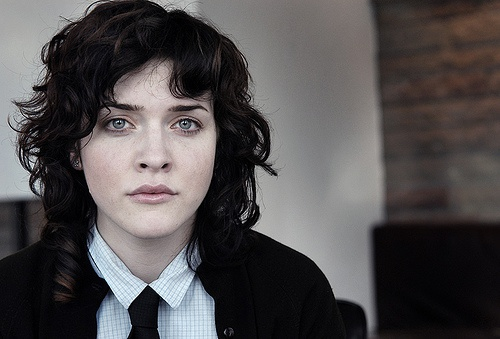Describe the objects in this image and their specific colors. I can see people in darkgray, black, lightgray, and gray tones and tie in darkgray, black, navy, and gray tones in this image. 